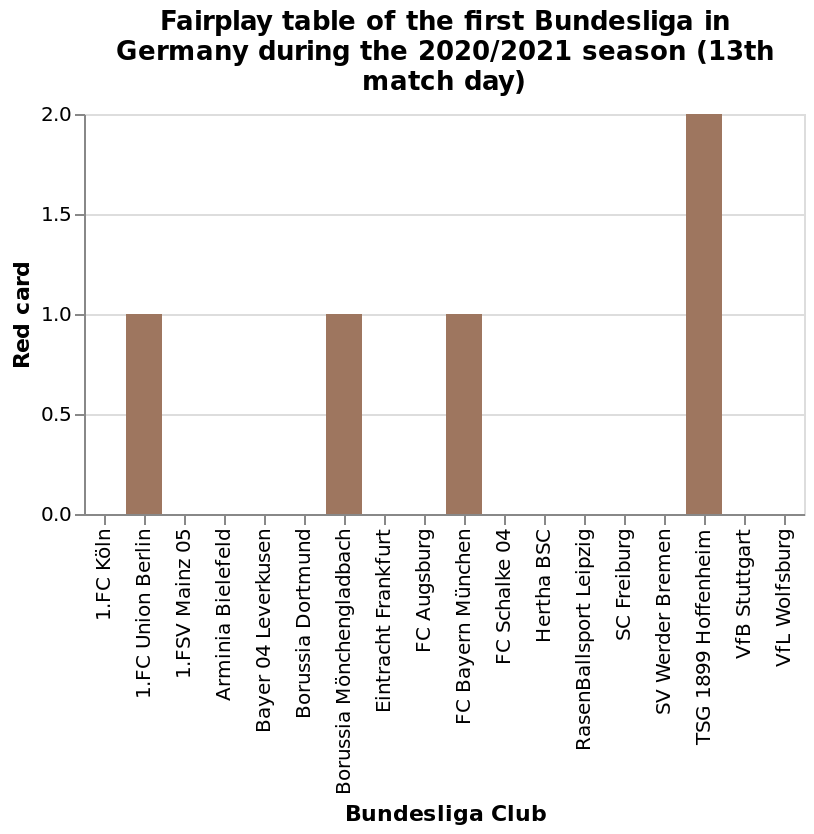<image>
please summary the statistics and relations of the chart Only 5 red cards were given in total during the season. These cards were given to 4 different clubs: Union Berlin, Borussia Monchegladbach, FC Bayern Munchen each recieved 1 red card. TSG 1899 Hoffenheim were the club who received the most red cards, and received 2 red cards. 